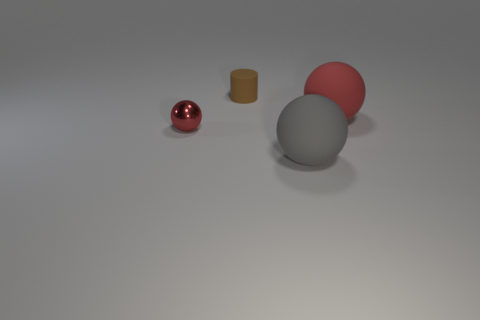Subtract all cyan cubes. How many red balls are left? 2 Subtract all red balls. How many balls are left? 1 Add 2 small shiny objects. How many objects exist? 6 Subtract all cylinders. How many objects are left? 3 Subtract all large gray objects. Subtract all tiny cylinders. How many objects are left? 2 Add 2 large matte things. How many large matte things are left? 4 Add 4 red rubber things. How many red rubber things exist? 5 Subtract 0 yellow spheres. How many objects are left? 4 Subtract all purple spheres. Subtract all blue blocks. How many spheres are left? 3 